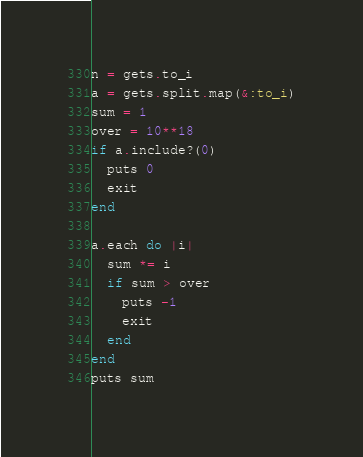Convert code to text. <code><loc_0><loc_0><loc_500><loc_500><_Ruby_>n = gets.to_i
a = gets.split.map(&:to_i)
sum = 1
over = 10**18
if a.include?(0)
  puts 0
  exit
end

a.each do |i|
  sum *= i
  if sum > over
    puts -1
    exit
  end
end
puts sum</code> 